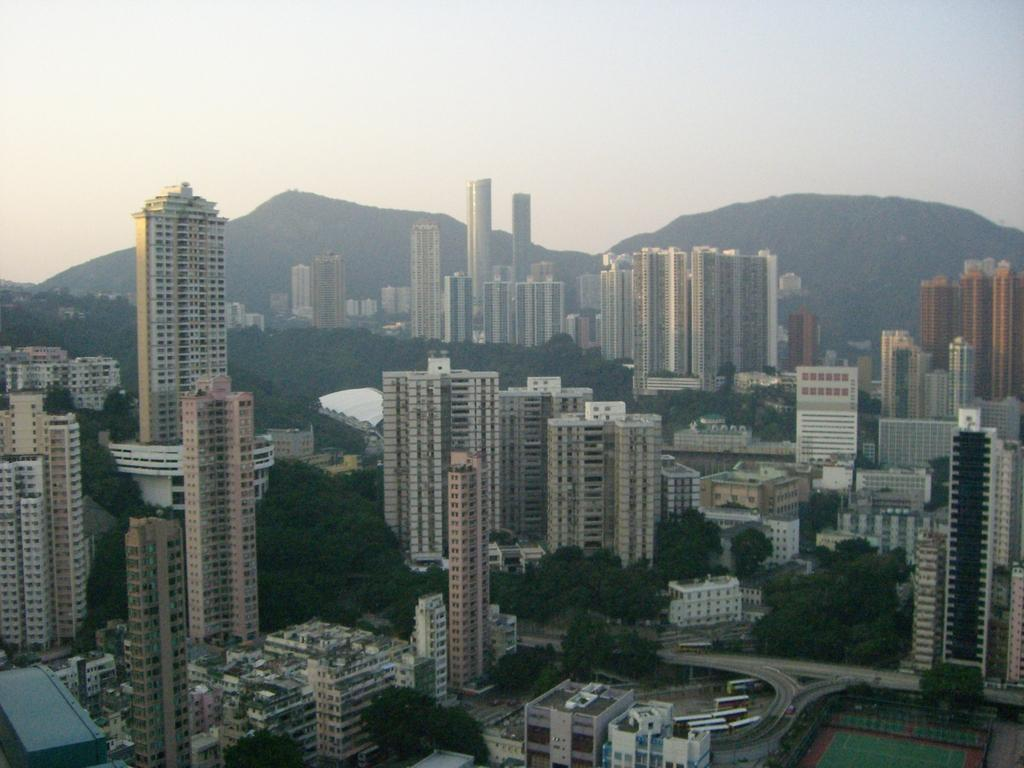What can be seen in the foreground of the image? There are buildings and trees in the foreground of the image. What is visible in the background of the image? There are mountains and the sky in the background of the image. What type of agreement is being signed in the image? There is no indication of an agreement or any signing activity in the image. What fictional character can be seen interacting with the trees in the image? There are no fictional characters present in the image; it features buildings, trees, mountains, and the sky. 